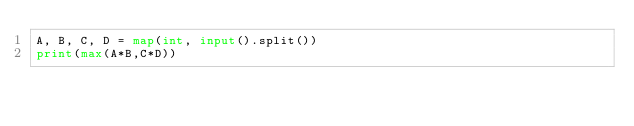Convert code to text. <code><loc_0><loc_0><loc_500><loc_500><_Python_>A, B, C, D = map(int, input().split())
print(max(A*B,C*D))</code> 